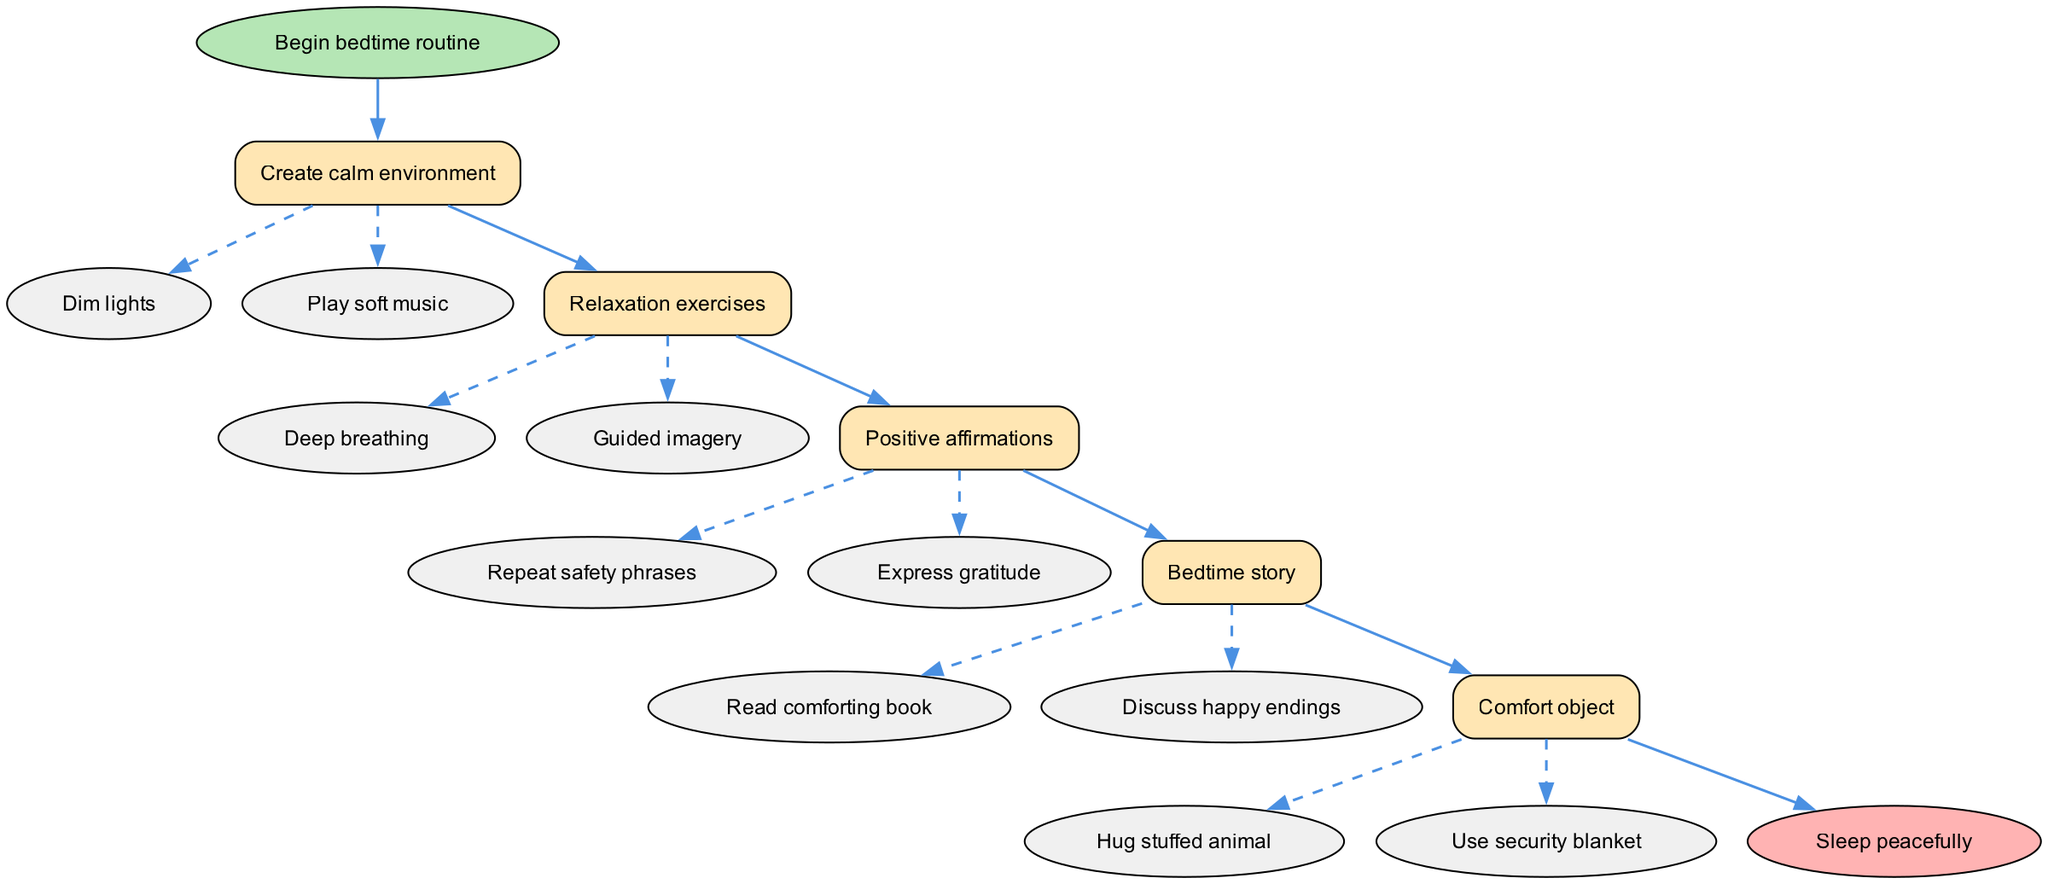What is the first step in the bedtime routine? The diagram shows that the first step listed is "Create calm environment." It can be found at the beginning of the flow, directly after the start node.
Answer: Create calm environment How many actions are there in the relaxation exercises step? In the "Relaxation exercises" step, there are two actions listed: "Deep breathing" and "Guided imagery." By counting these actions, we confirm the total.
Answer: 2 What do the dashed edges in the diagram represent? The dashed edges connect the steps to their respective actions, indicating that these are additional activities associated with each step, rather than primary steps themselves.
Answer: Actions What is the last step before going to sleep? The last step listed in the flow diagram before reaching "Sleep peacefully" is "Comfort object." This can be identified by following the flow from the initial step through to the end.
Answer: Comfort object Which step involves discussing happy endings? The step involving the action of discussing happy endings is "Bedtime story." This can be identified by looking at the actions listed under that particular step.
Answer: Bedtime story What colors are used to differentiate the step nodes from the start and end nodes? The diagram uses different colors to distinguish nodes: the step nodes are filled with a light yellow color (#FFE6B3), while the start node is a light green (#B5E6B5) and the end node is light red (#FFB3B3).
Answer: Yellow What is the final output of this bedtime routine? The final output, as indicated in the flow chart, is "Sleep peacefully," which is reached after completing the various steps in the routine.
Answer: Sleep peacefully How is a calming environment created according to the diagram? According to the diagram, a calming environment is created by two specific actions: "Dim lights" and "Play soft music." These actions are linked directly to the first step.
Answer: Dim lights, Play soft music What activity supports feelings of safety during the routine? The activity that supports feelings of safety is "Positive affirmations," which includes repeating safety phrases that boost a sense of security.
Answer: Positive affirmations 